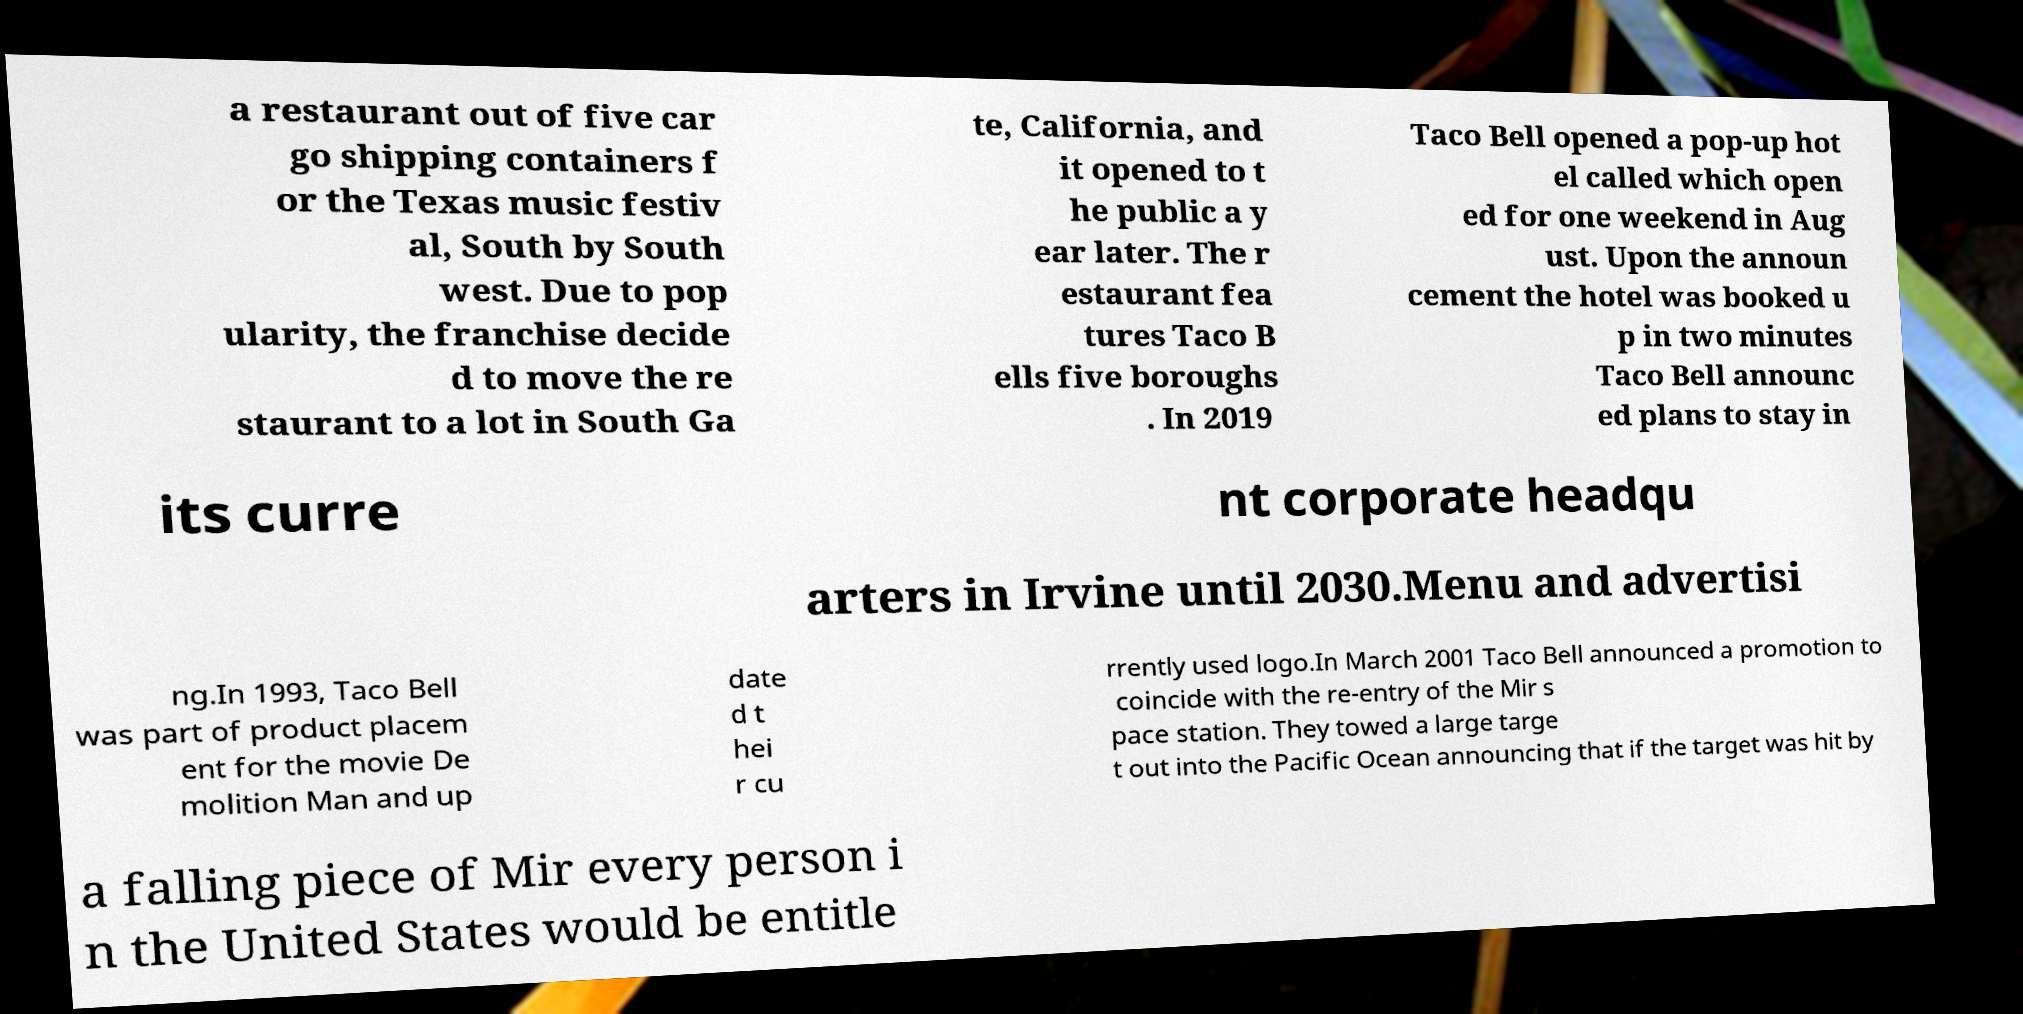Please identify and transcribe the text found in this image. a restaurant out of five car go shipping containers f or the Texas music festiv al, South by South west. Due to pop ularity, the franchise decide d to move the re staurant to a lot in South Ga te, California, and it opened to t he public a y ear later. The r estaurant fea tures Taco B ells five boroughs . In 2019 Taco Bell opened a pop-up hot el called which open ed for one weekend in Aug ust. Upon the announ cement the hotel was booked u p in two minutes Taco Bell announc ed plans to stay in its curre nt corporate headqu arters in Irvine until 2030.Menu and advertisi ng.In 1993, Taco Bell was part of product placem ent for the movie De molition Man and up date d t hei r cu rrently used logo.In March 2001 Taco Bell announced a promotion to coincide with the re-entry of the Mir s pace station. They towed a large targe t out into the Pacific Ocean announcing that if the target was hit by a falling piece of Mir every person i n the United States would be entitle 